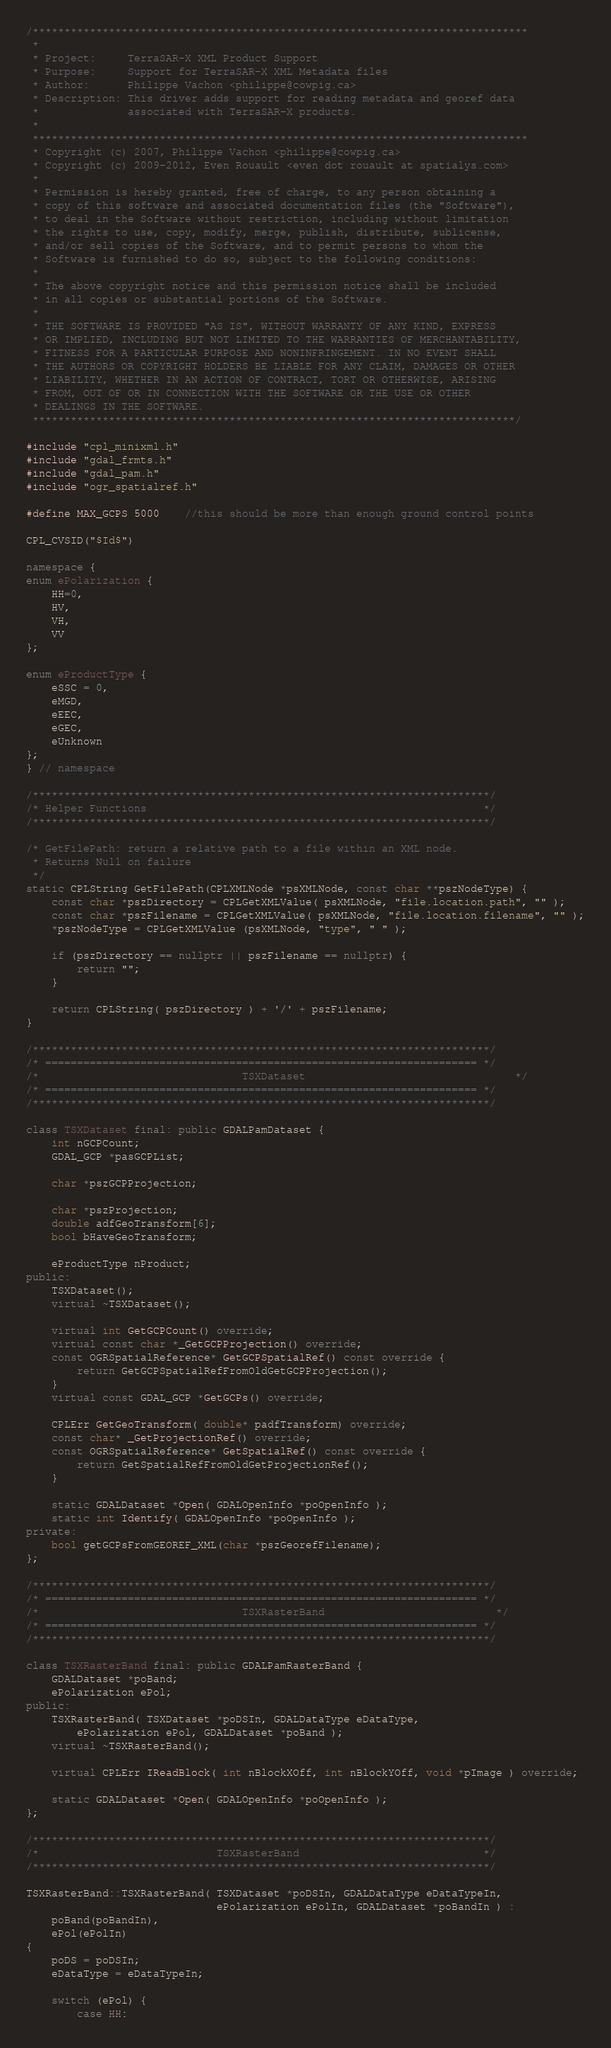<code> <loc_0><loc_0><loc_500><loc_500><_C++_>/******************************************************************************
 *
 * Project:     TerraSAR-X XML Product Support
 * Purpose:     Support for TerraSAR-X XML Metadata files
 * Author:      Philippe Vachon <philippe@cowpig.ca>
 * Description: This driver adds support for reading metadata and georef data
 *              associated with TerraSAR-X products.
 *
 ******************************************************************************
 * Copyright (c) 2007, Philippe Vachon <philippe@cowpig.ca>
 * Copyright (c) 2009-2012, Even Rouault <even dot rouault at spatialys.com>
 *
 * Permission is hereby granted, free of charge, to any person obtaining a
 * copy of this software and associated documentation files (the "Software"),
 * to deal in the Software without restriction, including without limitation
 * the rights to use, copy, modify, merge, publish, distribute, sublicense,
 * and/or sell copies of the Software, and to permit persons to whom the
 * Software is furnished to do so, subject to the following conditions:
 *
 * The above copyright notice and this permission notice shall be included
 * in all copies or substantial portions of the Software.
 *
 * THE SOFTWARE IS PROVIDED "AS IS", WITHOUT WARRANTY OF ANY KIND, EXPRESS
 * OR IMPLIED, INCLUDING BUT NOT LIMITED TO THE WARRANTIES OF MERCHANTABILITY,
 * FITNESS FOR A PARTICULAR PURPOSE AND NONINFRINGEMENT. IN NO EVENT SHALL
 * THE AUTHORS OR COPYRIGHT HOLDERS BE LIABLE FOR ANY CLAIM, DAMAGES OR OTHER
 * LIABILITY, WHETHER IN AN ACTION OF CONTRACT, TORT OR OTHERWISE, ARISING
 * FROM, OUT OF OR IN CONNECTION WITH THE SOFTWARE OR THE USE OR OTHER
 * DEALINGS IN THE SOFTWARE.
 ****************************************************************************/

#include "cpl_minixml.h"
#include "gdal_frmts.h"
#include "gdal_pam.h"
#include "ogr_spatialref.h"

#define MAX_GCPS 5000    //this should be more than enough ground control points

CPL_CVSID("$Id$")

namespace {
enum ePolarization {
    HH=0,
    HV,
    VH,
    VV
};

enum eProductType {
    eSSC = 0,
    eMGD,
    eEEC,
    eGEC,
    eUnknown
};
} // namespace

/************************************************************************/
/* Helper Functions                                                     */
/************************************************************************/

/* GetFilePath: return a relative path to a file within an XML node.
 * Returns Null on failure
 */
static CPLString GetFilePath(CPLXMLNode *psXMLNode, const char **pszNodeType) {
    const char *pszDirectory = CPLGetXMLValue( psXMLNode, "file.location.path", "" );
    const char *pszFilename = CPLGetXMLValue( psXMLNode, "file.location.filename", "" );
    *pszNodeType = CPLGetXMLValue (psXMLNode, "type", " " );

    if (pszDirectory == nullptr || pszFilename == nullptr) {
        return "";
    }

    return CPLString( pszDirectory ) + '/' + pszFilename;
}

/************************************************************************/
/* ==================================================================== */
/*                                TSXDataset                                 */
/* ==================================================================== */
/************************************************************************/

class TSXDataset final: public GDALPamDataset {
    int nGCPCount;
    GDAL_GCP *pasGCPList;

    char *pszGCPProjection;

    char *pszProjection;
    double adfGeoTransform[6];
    bool bHaveGeoTransform;

    eProductType nProduct;
public:
    TSXDataset();
    virtual ~TSXDataset();

    virtual int GetGCPCount() override;
    virtual const char *_GetGCPProjection() override;
    const OGRSpatialReference* GetGCPSpatialRef() const override {
        return GetGCPSpatialRefFromOldGetGCPProjection();
    }
    virtual const GDAL_GCP *GetGCPs() override;

    CPLErr GetGeoTransform( double* padfTransform) override;
    const char* _GetProjectionRef() override;
    const OGRSpatialReference* GetSpatialRef() const override {
        return GetSpatialRefFromOldGetProjectionRef();
    }

    static GDALDataset *Open( GDALOpenInfo *poOpenInfo );
    static int Identify( GDALOpenInfo *poOpenInfo );
private:
    bool getGCPsFromGEOREF_XML(char *pszGeorefFilename);
};

/************************************************************************/
/* ==================================================================== */
/*                                TSXRasterBand                           */
/* ==================================================================== */
/************************************************************************/

class TSXRasterBand final: public GDALPamRasterBand {
    GDALDataset *poBand;
    ePolarization ePol;
public:
    TSXRasterBand( TSXDataset *poDSIn, GDALDataType eDataType,
        ePolarization ePol, GDALDataset *poBand );
    virtual ~TSXRasterBand();

    virtual CPLErr IReadBlock( int nBlockXOff, int nBlockYOff, void *pImage ) override;

    static GDALDataset *Open( GDALOpenInfo *poOpenInfo );
};

/************************************************************************/
/*                            TSXRasterBand                             */
/************************************************************************/

TSXRasterBand::TSXRasterBand( TSXDataset *poDSIn, GDALDataType eDataTypeIn,
                              ePolarization ePolIn, GDALDataset *poBandIn ) :
    poBand(poBandIn),
    ePol(ePolIn)
{
    poDS = poDSIn;
    eDataType = eDataTypeIn;

    switch (ePol) {
        case HH:</code> 